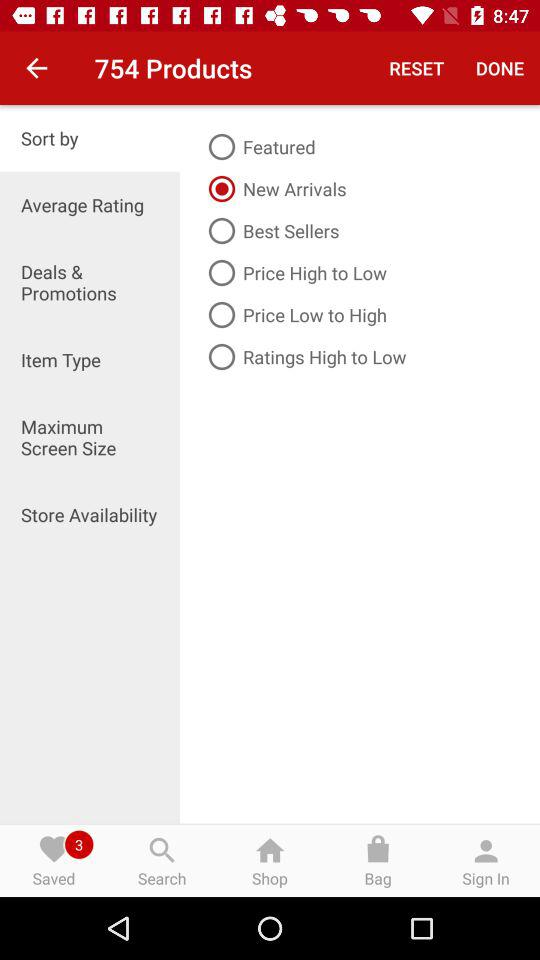What is the count of saved items? The count of saved items is 3. 